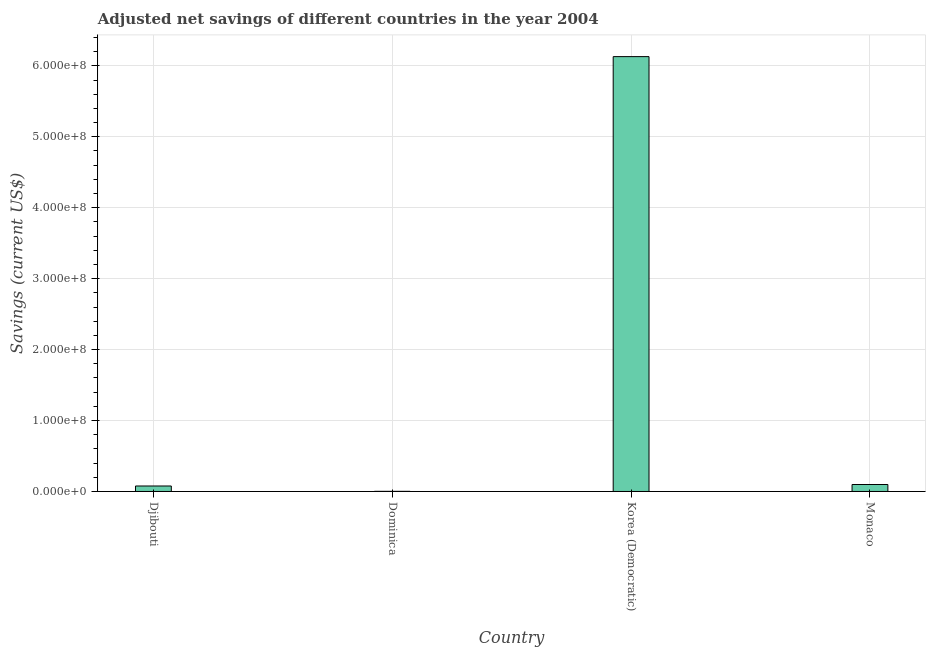Does the graph contain any zero values?
Your answer should be compact. No. What is the title of the graph?
Provide a succinct answer. Adjusted net savings of different countries in the year 2004. What is the label or title of the Y-axis?
Ensure brevity in your answer.  Savings (current US$). What is the adjusted net savings in Dominica?
Your response must be concise. 1.92e+05. Across all countries, what is the maximum adjusted net savings?
Provide a succinct answer. 6.13e+08. Across all countries, what is the minimum adjusted net savings?
Your response must be concise. 1.92e+05. In which country was the adjusted net savings maximum?
Your answer should be very brief. Korea (Democratic). In which country was the adjusted net savings minimum?
Offer a terse response. Dominica. What is the sum of the adjusted net savings?
Give a very brief answer. 6.31e+08. What is the difference between the adjusted net savings in Dominica and Monaco?
Ensure brevity in your answer.  -9.62e+06. What is the average adjusted net savings per country?
Your answer should be very brief. 1.58e+08. What is the median adjusted net savings?
Offer a terse response. 8.77e+06. What is the ratio of the adjusted net savings in Dominica to that in Korea (Democratic)?
Your answer should be very brief. 0. What is the difference between the highest and the second highest adjusted net savings?
Make the answer very short. 6.03e+08. Is the sum of the adjusted net savings in Dominica and Monaco greater than the maximum adjusted net savings across all countries?
Provide a succinct answer. No. What is the difference between the highest and the lowest adjusted net savings?
Provide a short and direct response. 6.13e+08. In how many countries, is the adjusted net savings greater than the average adjusted net savings taken over all countries?
Your response must be concise. 1. How many countries are there in the graph?
Provide a succinct answer. 4. Are the values on the major ticks of Y-axis written in scientific E-notation?
Offer a terse response. Yes. What is the Savings (current US$) in Djibouti?
Keep it short and to the point. 7.73e+06. What is the Savings (current US$) of Dominica?
Offer a terse response. 1.92e+05. What is the Savings (current US$) in Korea (Democratic)?
Your answer should be very brief. 6.13e+08. What is the Savings (current US$) in Monaco?
Ensure brevity in your answer.  9.82e+06. What is the difference between the Savings (current US$) in Djibouti and Dominica?
Provide a short and direct response. 7.53e+06. What is the difference between the Savings (current US$) in Djibouti and Korea (Democratic)?
Offer a very short reply. -6.05e+08. What is the difference between the Savings (current US$) in Djibouti and Monaco?
Ensure brevity in your answer.  -2.09e+06. What is the difference between the Savings (current US$) in Dominica and Korea (Democratic)?
Your answer should be compact. -6.13e+08. What is the difference between the Savings (current US$) in Dominica and Monaco?
Provide a short and direct response. -9.62e+06. What is the difference between the Savings (current US$) in Korea (Democratic) and Monaco?
Make the answer very short. 6.03e+08. What is the ratio of the Savings (current US$) in Djibouti to that in Dominica?
Give a very brief answer. 40.31. What is the ratio of the Savings (current US$) in Djibouti to that in Korea (Democratic)?
Your answer should be very brief. 0.01. What is the ratio of the Savings (current US$) in Djibouti to that in Monaco?
Ensure brevity in your answer.  0.79. What is the ratio of the Savings (current US$) in Korea (Democratic) to that in Monaco?
Offer a terse response. 62.45. 